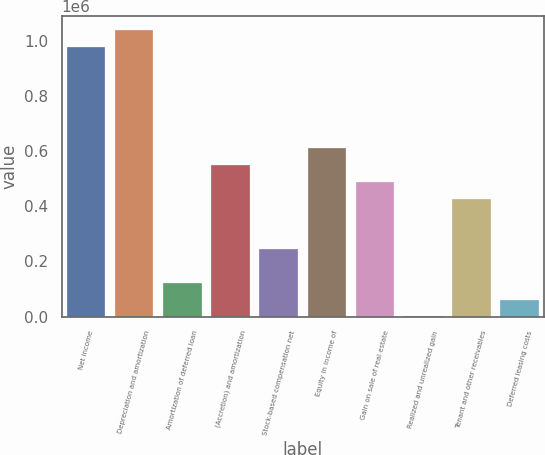Convert chart to OTSL. <chart><loc_0><loc_0><loc_500><loc_500><bar_chart><fcel>Net income<fcel>Depreciation and amortization<fcel>Amortization of deferred loan<fcel>(Accretion) and amortization<fcel>Stock-based compensation net<fcel>Equity in income of<fcel>Gain on sale of real estate<fcel>Realized and unrealized gain<fcel>Tenant and other receivables<fcel>Deferred leasing costs<nl><fcel>975817<fcel>1.03673e+06<fcel>123007<fcel>549412<fcel>244837<fcel>610327<fcel>488497<fcel>1177<fcel>427582<fcel>62092<nl></chart> 